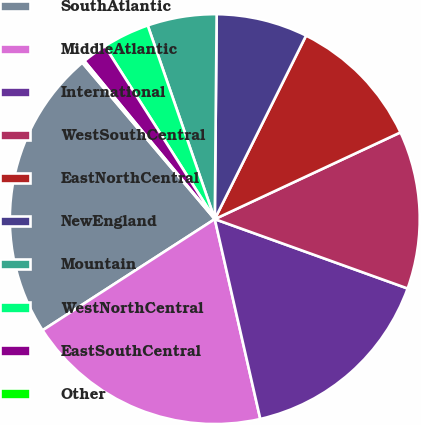Convert chart to OTSL. <chart><loc_0><loc_0><loc_500><loc_500><pie_chart><fcel>SouthAtlantic<fcel>MiddleAtlantic<fcel>International<fcel>WestSouthCentral<fcel>EastNorthCentral<fcel>NewEngland<fcel>Mountain<fcel>WestNorthCentral<fcel>EastSouthCentral<fcel>Other<nl><fcel>22.94%<fcel>19.44%<fcel>15.94%<fcel>12.45%<fcel>10.7%<fcel>7.2%<fcel>5.45%<fcel>3.71%<fcel>1.96%<fcel>0.21%<nl></chart> 